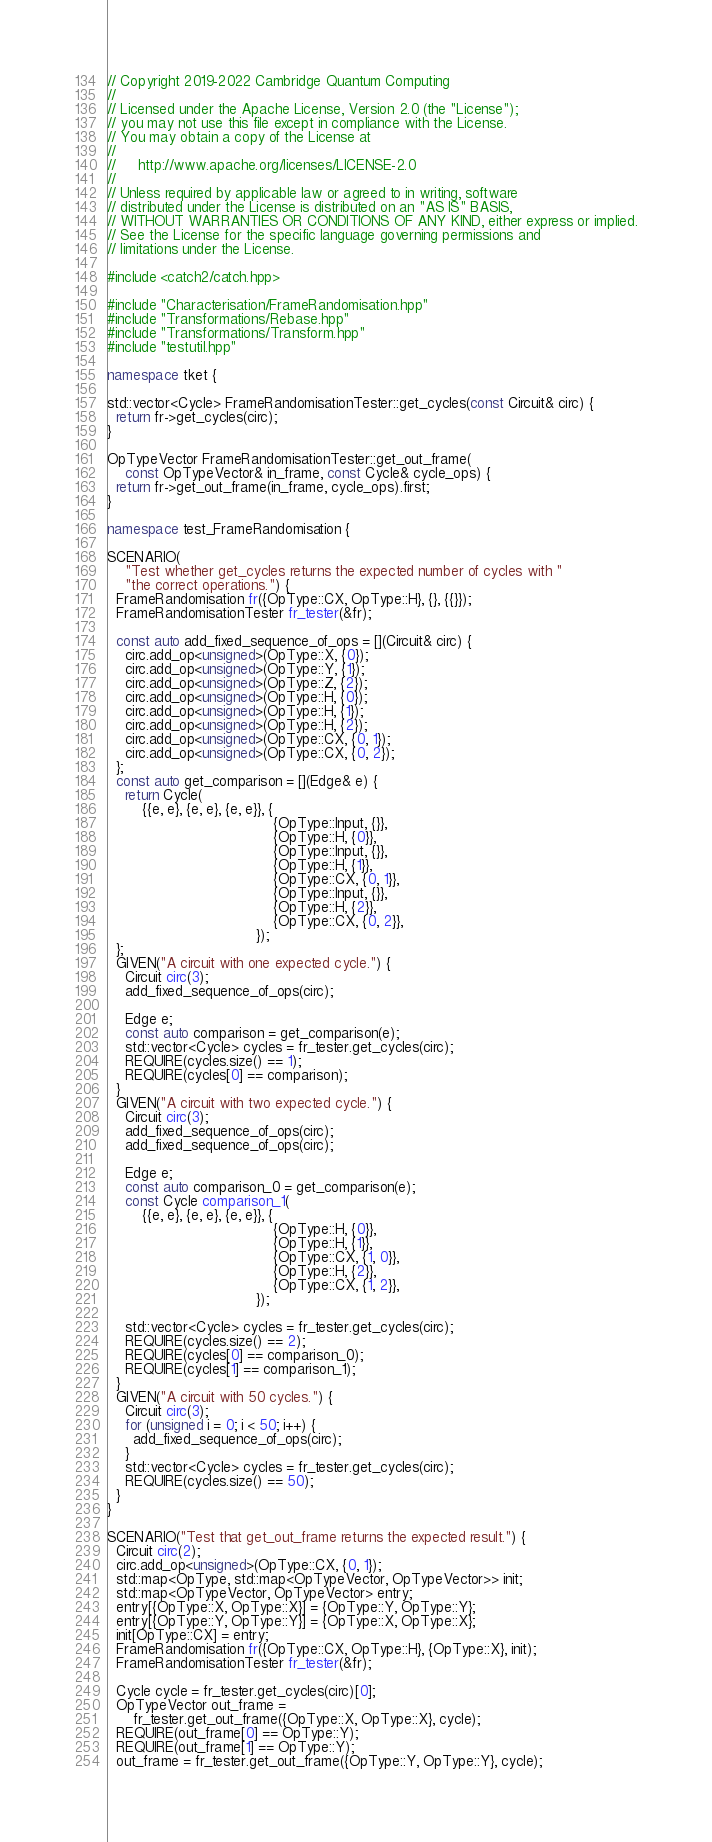<code> <loc_0><loc_0><loc_500><loc_500><_C++_>// Copyright 2019-2022 Cambridge Quantum Computing
//
// Licensed under the Apache License, Version 2.0 (the "License");
// you may not use this file except in compliance with the License.
// You may obtain a copy of the License at
//
//     http://www.apache.org/licenses/LICENSE-2.0
//
// Unless required by applicable law or agreed to in writing, software
// distributed under the License is distributed on an "AS IS" BASIS,
// WITHOUT WARRANTIES OR CONDITIONS OF ANY KIND, either express or implied.
// See the License for the specific language governing permissions and
// limitations under the License.

#include <catch2/catch.hpp>

#include "Characterisation/FrameRandomisation.hpp"
#include "Transformations/Rebase.hpp"
#include "Transformations/Transform.hpp"
#include "testutil.hpp"

namespace tket {

std::vector<Cycle> FrameRandomisationTester::get_cycles(const Circuit& circ) {
  return fr->get_cycles(circ);
}

OpTypeVector FrameRandomisationTester::get_out_frame(
    const OpTypeVector& in_frame, const Cycle& cycle_ops) {
  return fr->get_out_frame(in_frame, cycle_ops).first;
}

namespace test_FrameRandomisation {

SCENARIO(
    "Test whether get_cycles returns the expected number of cycles with "
    "the correct operations.") {
  FrameRandomisation fr({OpType::CX, OpType::H}, {}, {{}});
  FrameRandomisationTester fr_tester(&fr);

  const auto add_fixed_sequence_of_ops = [](Circuit& circ) {
    circ.add_op<unsigned>(OpType::X, {0});
    circ.add_op<unsigned>(OpType::Y, {1});
    circ.add_op<unsigned>(OpType::Z, {2});
    circ.add_op<unsigned>(OpType::H, {0});
    circ.add_op<unsigned>(OpType::H, {1});
    circ.add_op<unsigned>(OpType::H, {2});
    circ.add_op<unsigned>(OpType::CX, {0, 1});
    circ.add_op<unsigned>(OpType::CX, {0, 2});
  };
  const auto get_comparison = [](Edge& e) {
    return Cycle(
        {{e, e}, {e, e}, {e, e}}, {
                                      {OpType::Input, {}},
                                      {OpType::H, {0}},
                                      {OpType::Input, {}},
                                      {OpType::H, {1}},
                                      {OpType::CX, {0, 1}},
                                      {OpType::Input, {}},
                                      {OpType::H, {2}},
                                      {OpType::CX, {0, 2}},
                                  });
  };
  GIVEN("A circuit with one expected cycle.") {
    Circuit circ(3);
    add_fixed_sequence_of_ops(circ);

    Edge e;
    const auto comparison = get_comparison(e);
    std::vector<Cycle> cycles = fr_tester.get_cycles(circ);
    REQUIRE(cycles.size() == 1);
    REQUIRE(cycles[0] == comparison);
  }
  GIVEN("A circuit with two expected cycle.") {
    Circuit circ(3);
    add_fixed_sequence_of_ops(circ);
    add_fixed_sequence_of_ops(circ);

    Edge e;
    const auto comparison_0 = get_comparison(e);
    const Cycle comparison_1(
        {{e, e}, {e, e}, {e, e}}, {
                                      {OpType::H, {0}},
                                      {OpType::H, {1}},
                                      {OpType::CX, {1, 0}},
                                      {OpType::H, {2}},
                                      {OpType::CX, {1, 2}},
                                  });

    std::vector<Cycle> cycles = fr_tester.get_cycles(circ);
    REQUIRE(cycles.size() == 2);
    REQUIRE(cycles[0] == comparison_0);
    REQUIRE(cycles[1] == comparison_1);
  }
  GIVEN("A circuit with 50 cycles.") {
    Circuit circ(3);
    for (unsigned i = 0; i < 50; i++) {
      add_fixed_sequence_of_ops(circ);
    }
    std::vector<Cycle> cycles = fr_tester.get_cycles(circ);
    REQUIRE(cycles.size() == 50);
  }
}

SCENARIO("Test that get_out_frame returns the expected result.") {
  Circuit circ(2);
  circ.add_op<unsigned>(OpType::CX, {0, 1});
  std::map<OpType, std::map<OpTypeVector, OpTypeVector>> init;
  std::map<OpTypeVector, OpTypeVector> entry;
  entry[{OpType::X, OpType::X}] = {OpType::Y, OpType::Y};
  entry[{OpType::Y, OpType::Y}] = {OpType::X, OpType::X};
  init[OpType::CX] = entry;
  FrameRandomisation fr({OpType::CX, OpType::H}, {OpType::X}, init);
  FrameRandomisationTester fr_tester(&fr);

  Cycle cycle = fr_tester.get_cycles(circ)[0];
  OpTypeVector out_frame =
      fr_tester.get_out_frame({OpType::X, OpType::X}, cycle);
  REQUIRE(out_frame[0] == OpType::Y);
  REQUIRE(out_frame[1] == OpType::Y);
  out_frame = fr_tester.get_out_frame({OpType::Y, OpType::Y}, cycle);</code> 